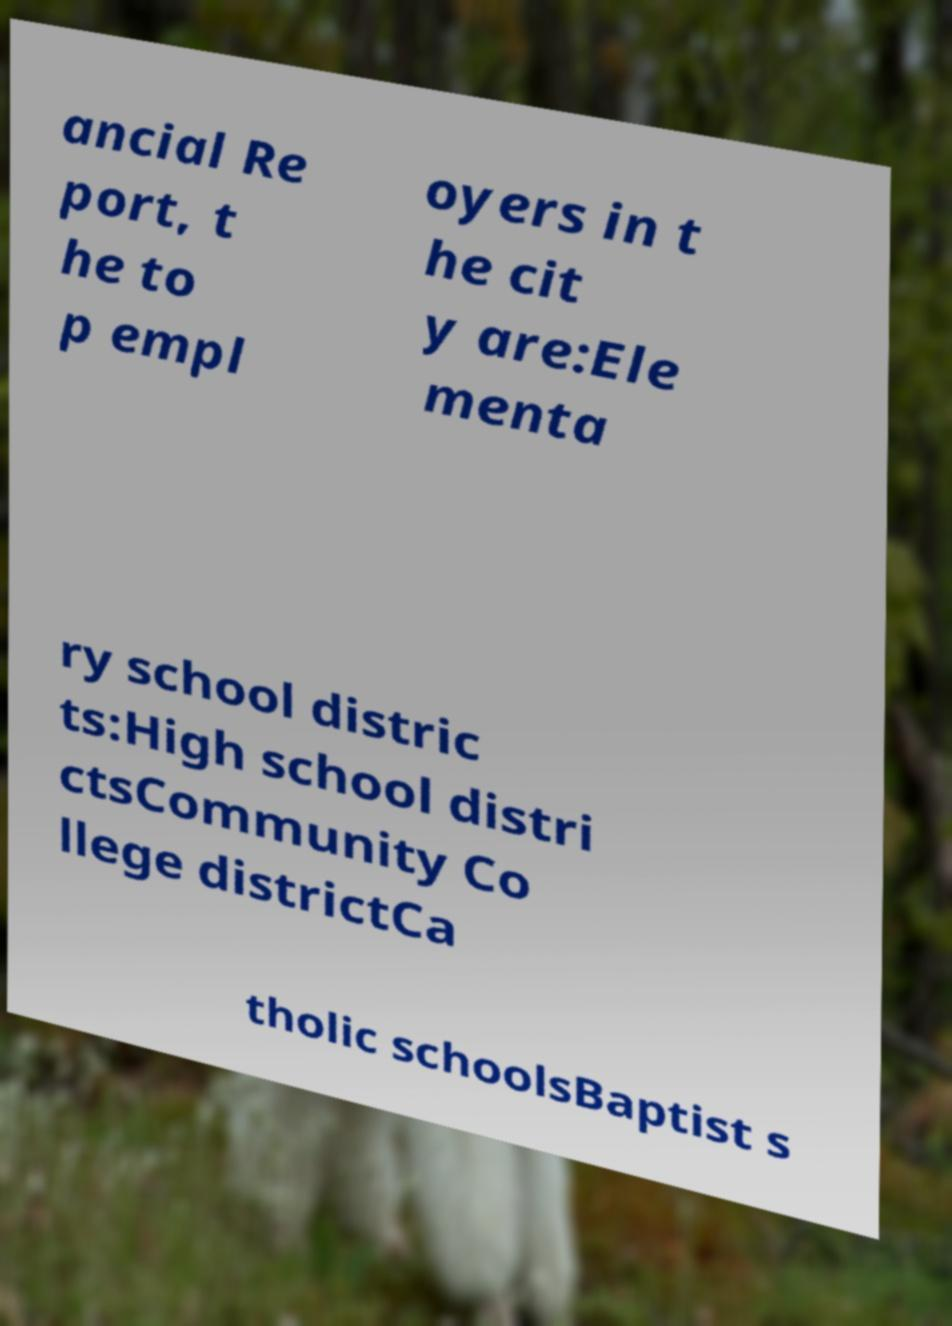Can you read and provide the text displayed in the image?This photo seems to have some interesting text. Can you extract and type it out for me? ancial Re port, t he to p empl oyers in t he cit y are:Ele menta ry school distric ts:High school distri ctsCommunity Co llege districtCa tholic schoolsBaptist s 